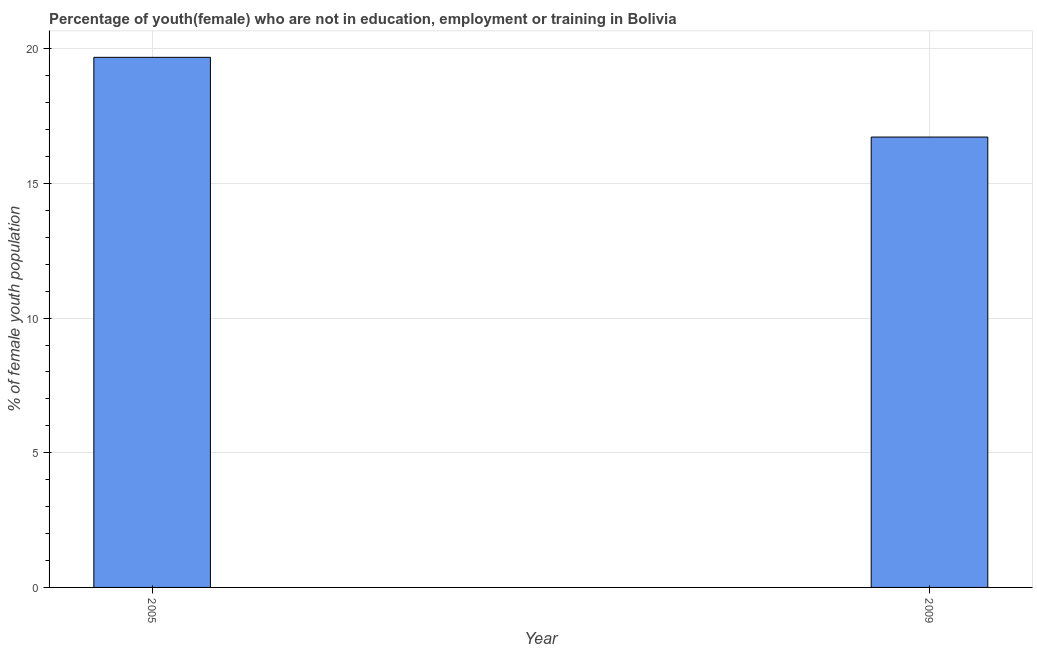What is the title of the graph?
Ensure brevity in your answer.  Percentage of youth(female) who are not in education, employment or training in Bolivia. What is the label or title of the Y-axis?
Provide a short and direct response. % of female youth population. What is the unemployed female youth population in 2009?
Make the answer very short. 16.72. Across all years, what is the maximum unemployed female youth population?
Offer a terse response. 19.68. Across all years, what is the minimum unemployed female youth population?
Provide a short and direct response. 16.72. In which year was the unemployed female youth population maximum?
Provide a short and direct response. 2005. What is the sum of the unemployed female youth population?
Ensure brevity in your answer.  36.4. What is the difference between the unemployed female youth population in 2005 and 2009?
Ensure brevity in your answer.  2.96. What is the median unemployed female youth population?
Your answer should be very brief. 18.2. In how many years, is the unemployed female youth population greater than 10 %?
Your response must be concise. 2. What is the ratio of the unemployed female youth population in 2005 to that in 2009?
Provide a succinct answer. 1.18. Is the unemployed female youth population in 2005 less than that in 2009?
Keep it short and to the point. No. In how many years, is the unemployed female youth population greater than the average unemployed female youth population taken over all years?
Your answer should be compact. 1. How many bars are there?
Your response must be concise. 2. What is the % of female youth population in 2005?
Ensure brevity in your answer.  19.68. What is the % of female youth population in 2009?
Offer a very short reply. 16.72. What is the difference between the % of female youth population in 2005 and 2009?
Your answer should be compact. 2.96. What is the ratio of the % of female youth population in 2005 to that in 2009?
Provide a short and direct response. 1.18. 